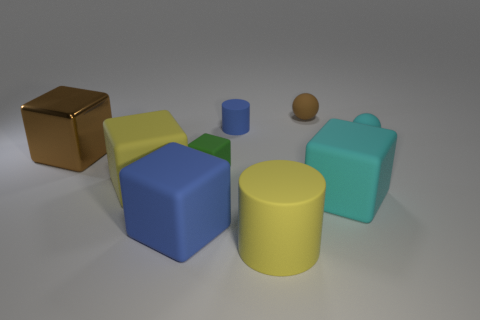What number of things are red metal objects or small green rubber blocks?
Provide a short and direct response. 1. What number of other objects are the same color as the large matte cylinder?
Keep it short and to the point. 1. The green rubber object that is the same size as the cyan sphere is what shape?
Your answer should be very brief. Cube. What color is the large cube behind the big yellow block?
Your answer should be very brief. Brown. What number of things are cyan things that are on the right side of the big cyan object or cylinders in front of the tiny cyan thing?
Offer a very short reply. 2. Do the blue cylinder and the blue matte cube have the same size?
Provide a short and direct response. No. How many cubes are either small red shiny things or big yellow things?
Offer a terse response. 1. How many cubes are to the right of the yellow block and left of the tiny green object?
Make the answer very short. 1. Do the cyan block and the yellow matte cylinder left of the small cyan sphere have the same size?
Keep it short and to the point. Yes. Is there a tiny cube behind the rubber block that is on the right side of the cylinder in front of the metallic cube?
Ensure brevity in your answer.  Yes. 